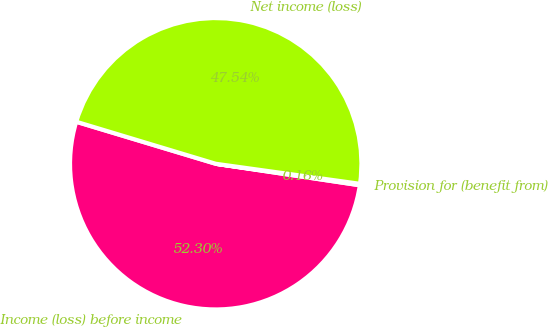<chart> <loc_0><loc_0><loc_500><loc_500><pie_chart><fcel>Income (loss) before income<fcel>Provision for (benefit from)<fcel>Net income (loss)<nl><fcel>52.3%<fcel>0.16%<fcel>47.54%<nl></chart> 